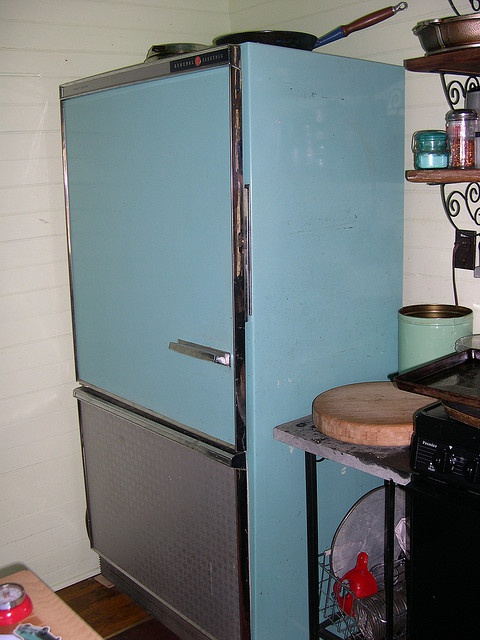Describe the objects in this image and their specific colors. I can see a refrigerator in gray, darkgray, and black tones in this image. 